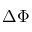Convert formula to latex. <formula><loc_0><loc_0><loc_500><loc_500>\Delta \Phi</formula> 